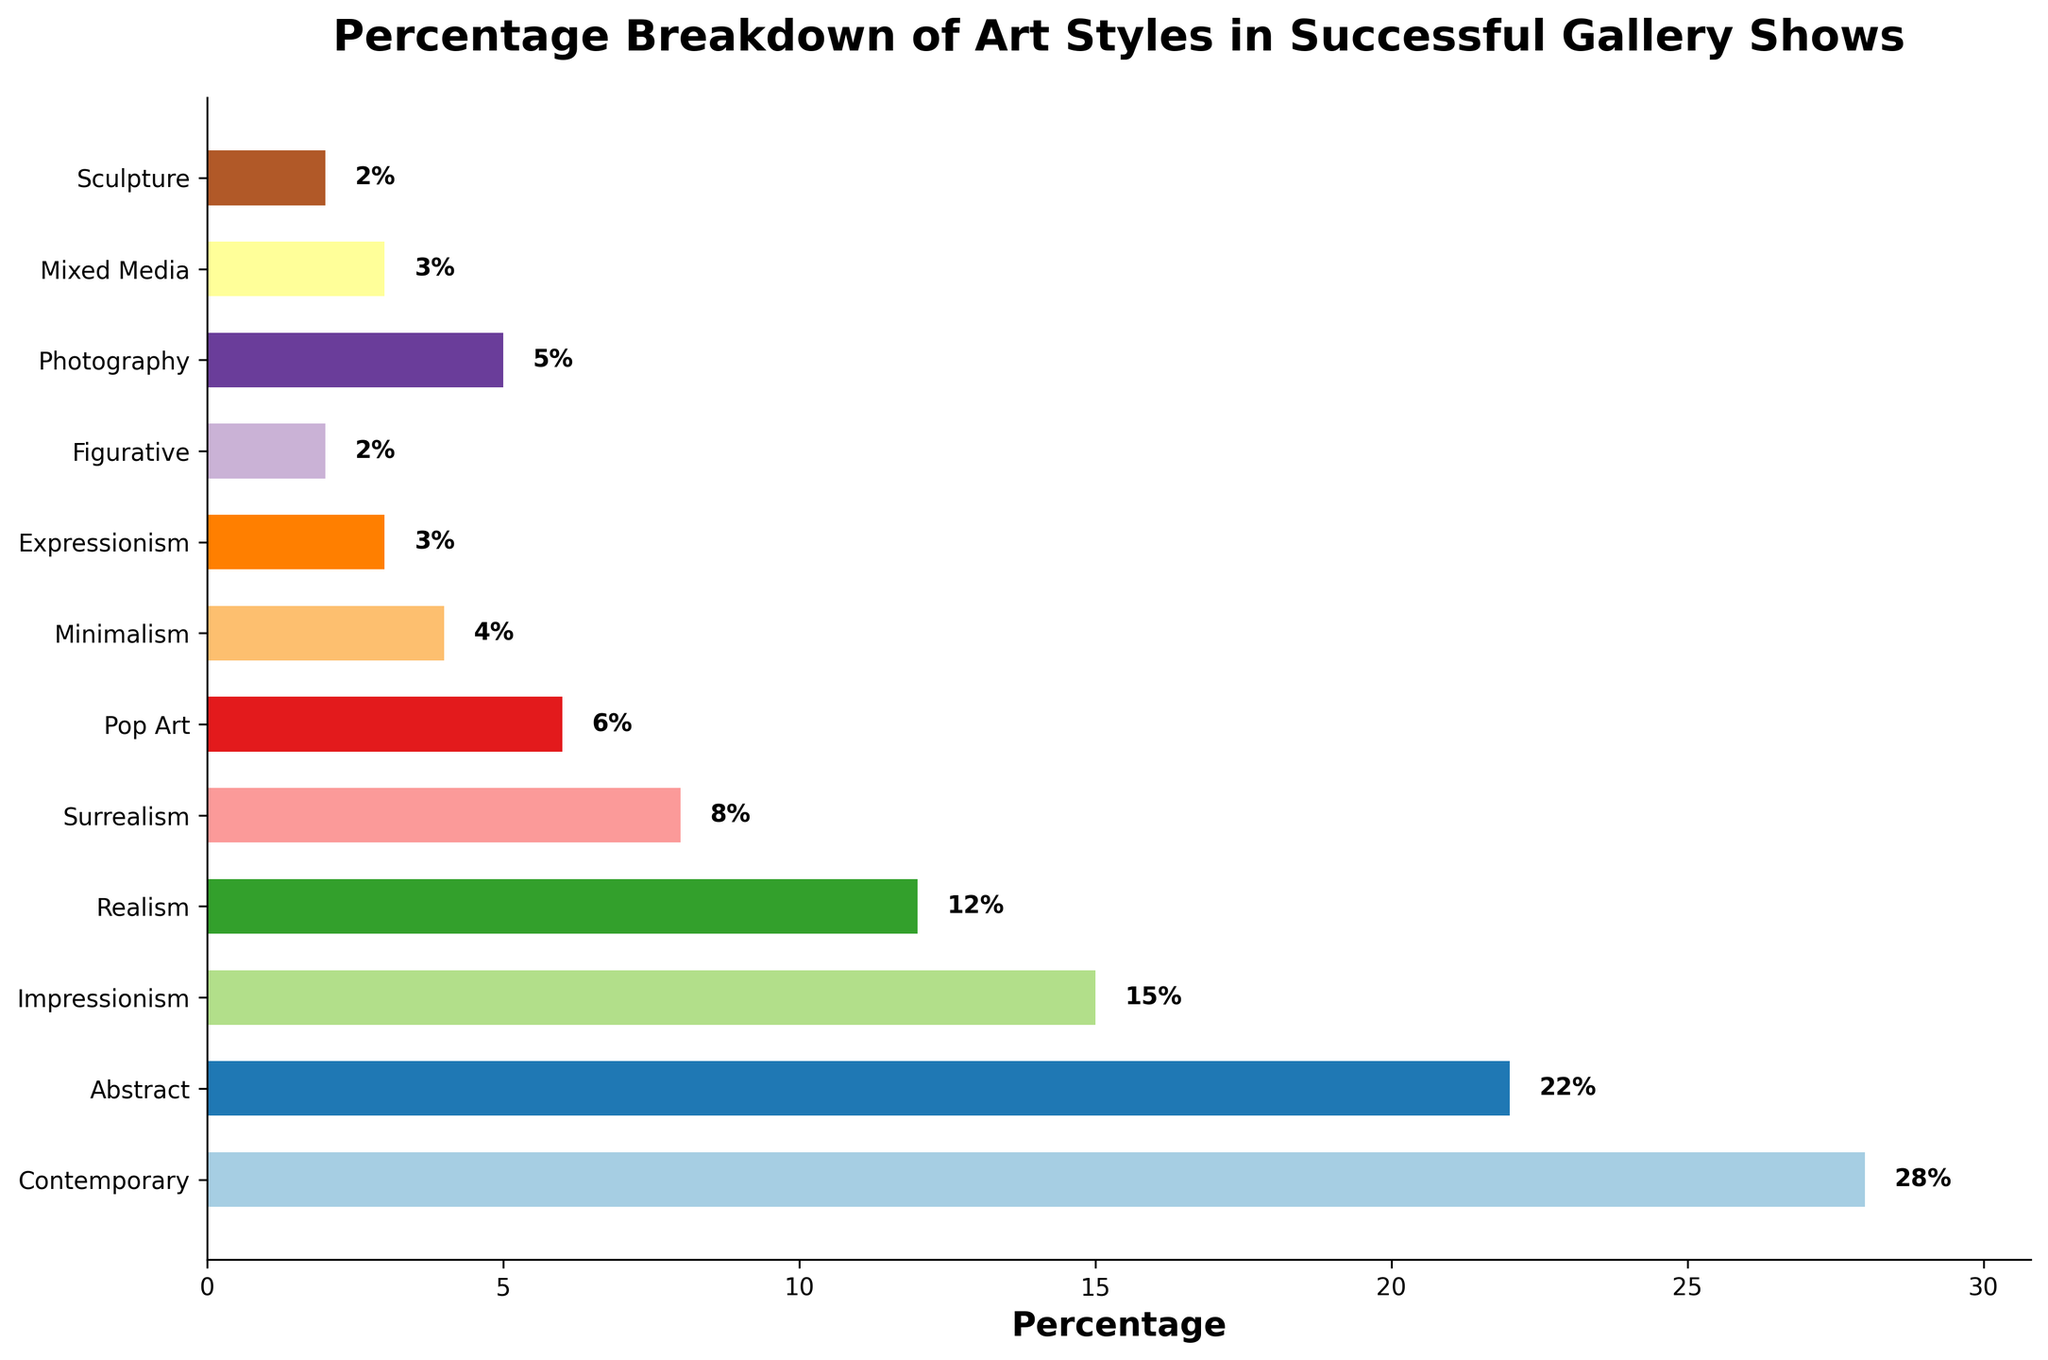What's the most represented art style in successful gallery shows? The art style with the highest percentage is the most represented. Look at the bar for Contemporary art, which has the longest length indicating 28%.
Answer: Contemporary What is the least represented art style in successful gallery shows? The least represented art style has the shortest bar. Both Figurative and Sculpture art have the shortest bars, each indicating 2%.
Answer: Figurative and Sculpture Which two art styles together constitute nearly half of the successful gallery shows? Sum the percentages of the two highest art styles. Contemporary is 28% and Abstract is 22%. Together, they add up to 50%.
Answer: Contemporary and Abstract Is Pop Art more represented than Photography? Compare the lengths of the bars for Pop Art and Photography. Pop Art is at 6% while Photography is at 5%, indicating Pop Art is slightly more represented.
Answer: Yes How many art styles constitute exactly one quarter of the total percentage? Identify art styles whose sum adds up to 25%. Realism is 12%, Surrealism is 8%, and Pop Art is 6%, together they sum to 26%, slightly over 25%. Minimalism at 4% and Expressionism at 3% added sums to 7%, so these together do not. This leaves Mixed Media at 3%, Sculpture and Figurative at 2% each, summing to 7%, far away from 25%. Finally, Impressionism at 15% alone adds to just above quarter percentage. There are no exact matches for 25%
Answer: None What are the visual characteristics of the bar representing Impressionism? The Impressionism bar is the third tallest, occupying about 15% of the chart's horizontal axis. The color is distinguishable from others around it.
Answer: 15%, third tallest Is Expressionism represented more than Mixed Media? Compare the bar lengths for Expressionism and Mixed Media. Both have bars indicating they represent 3% of the successful gallery shows.
Answer: No What is the difference in representation percentage between Contemporary and Realism? Subtract the percentage of Realism from Contemporary. Contemporary is at 28% and Realism is at 12%. The difference is 28% - 12% = 16%.
Answer: 16% Which art styles, when summed together, represent less than Contemporary? Identify art styles whose combined percentages sum to less than 28%. Summing up percentages we have Impressionism (15%) + Surrealism (8%) = 23%, Photography (5%) + Pop Art (6%) = 11%. Both are less. Combining minimalism (4%) + Expressionism (3%) = 7%, way less. So, Pop may come next choice taken into account along, leaving out large 4% + 3% else.
Answer: Impressionism, Surrealism, Pop Art, Photography 